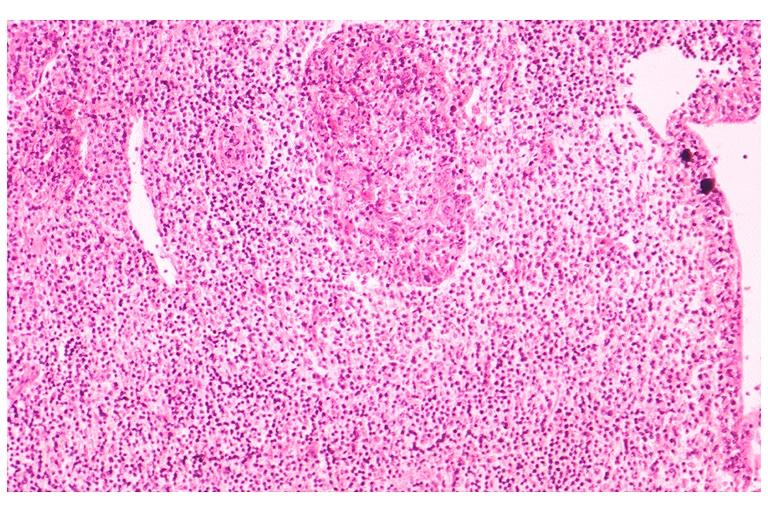s oral present?
Answer the question using a single word or phrase. Yes 